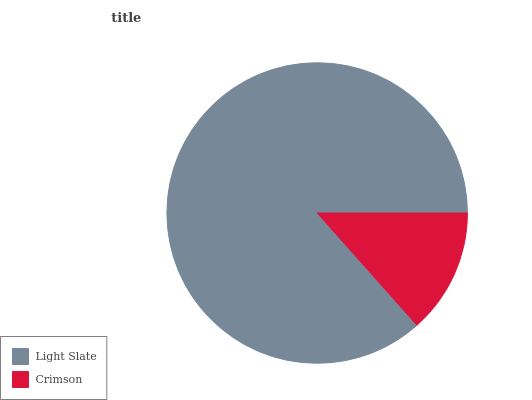Is Crimson the minimum?
Answer yes or no. Yes. Is Light Slate the maximum?
Answer yes or no. Yes. Is Crimson the maximum?
Answer yes or no. No. Is Light Slate greater than Crimson?
Answer yes or no. Yes. Is Crimson less than Light Slate?
Answer yes or no. Yes. Is Crimson greater than Light Slate?
Answer yes or no. No. Is Light Slate less than Crimson?
Answer yes or no. No. Is Light Slate the high median?
Answer yes or no. Yes. Is Crimson the low median?
Answer yes or no. Yes. Is Crimson the high median?
Answer yes or no. No. Is Light Slate the low median?
Answer yes or no. No. 